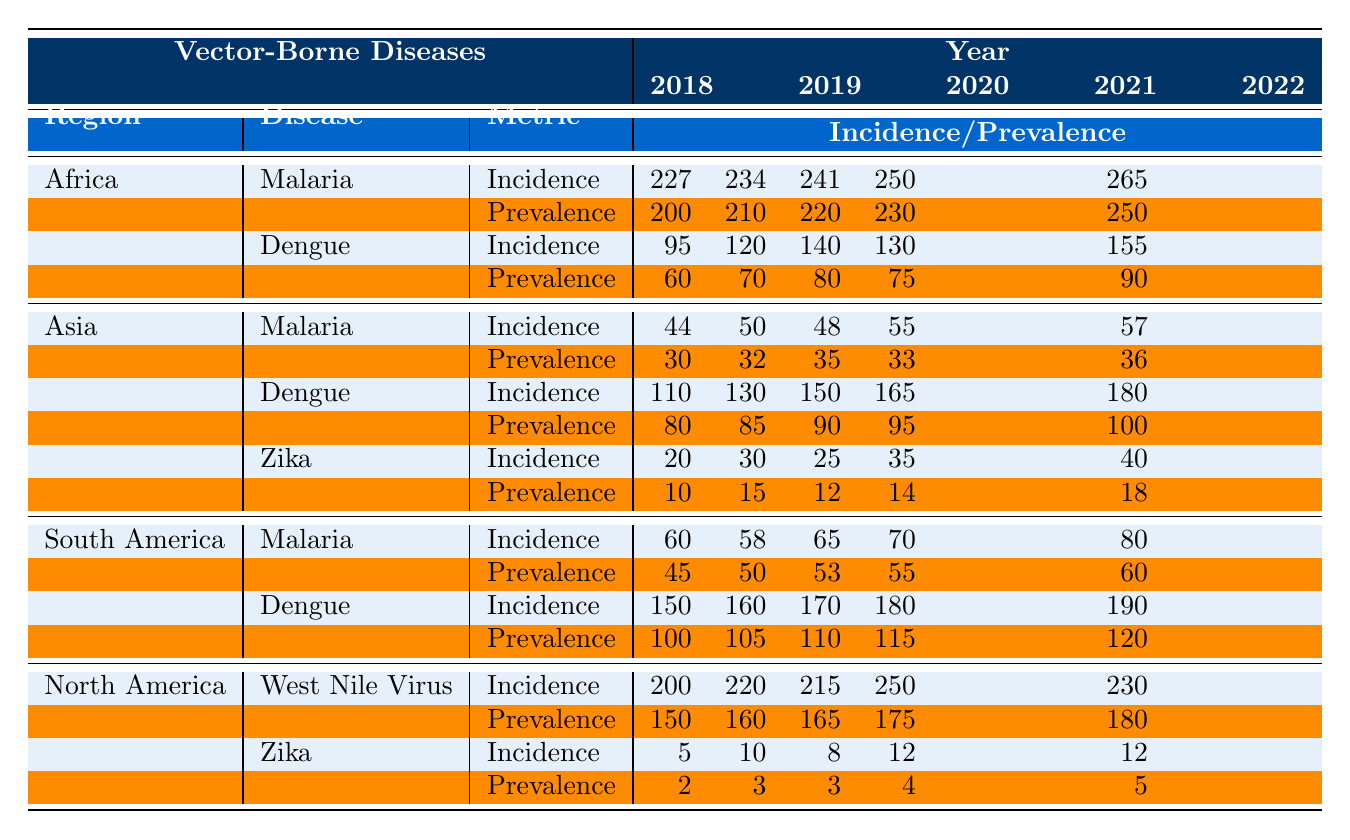What was the incidence of Malaria in Africa in 2022? According to the table, the incidence of Malaria in Africa for the year 2022 is specified as 265.
Answer: 265 What is the prevalence of Dengue in Asia for the year 2019? The table indicates that the prevalence of Dengue in Asia for 2019 is 85.
Answer: 85 Which region has the highest incidence of Zika and what is that value? From the table, North America has the highest incidence of Zika, recorded at 12 for the year 2022.
Answer: 12 What is the average incidence of Malaria in South America over the years from 2018 to 2022? To find the average, sum the incidence values: (60 + 58 + 65 + 70 + 80) = 333. There are 5 years, so the average is 333/5 = 66.6.
Answer: 66.6 Did the incidence of West Nile Virus in North America increase between 2020 and 2021? The incidence in 2020 was 215, and in 2021 it rose to 250, indicating an increase.
Answer: Yes What was the trend in incidence of Dengue in Africa from 2018 to 2022? The incidence values for Dengue in Africa are: 95 (2018), 120 (2019), 140 (2020), 130 (2021), and 155 (2022). The values show an overall increasing trend, except for a slight drop from 2020 to 2021.
Answer: Generally increasing, except for a drop in 2021 What region had the lowest prevalence of Zika in 2020 and what was the value? In 2020, the prevalence of Zika in North America was recorded at 3, which is lower compared to the prevalence in Asia which was 12. Thus, North America had the lowest.
Answer: 3 What is the total incidence of Dengue in Asia from 2018 to 2022? Summing the incidence values for Dengue in Asia gives: (110 + 130 + 150 + 165 + 180) = 735.
Answer: 735 How many vector-borne diseases have recorded data for North America? The table indicates that there are two vector-borne diseases with data for North America: West Nile Virus and Zika.
Answer: 2 What is the difference in prevalence of Malaria between Africa and Asia in 2021? The prevalence of Malaria in Africa in 2021 is 230 and in Asia it is 33. The difference is 230 - 33 = 197.
Answer: 197 Which disease had the highest prevalence in South America in 2022? In South America, the prevalence of Dengue in 2022 is 120 and Malaria is 60, thus Dengue had the highest prevalence.
Answer: Dengue 